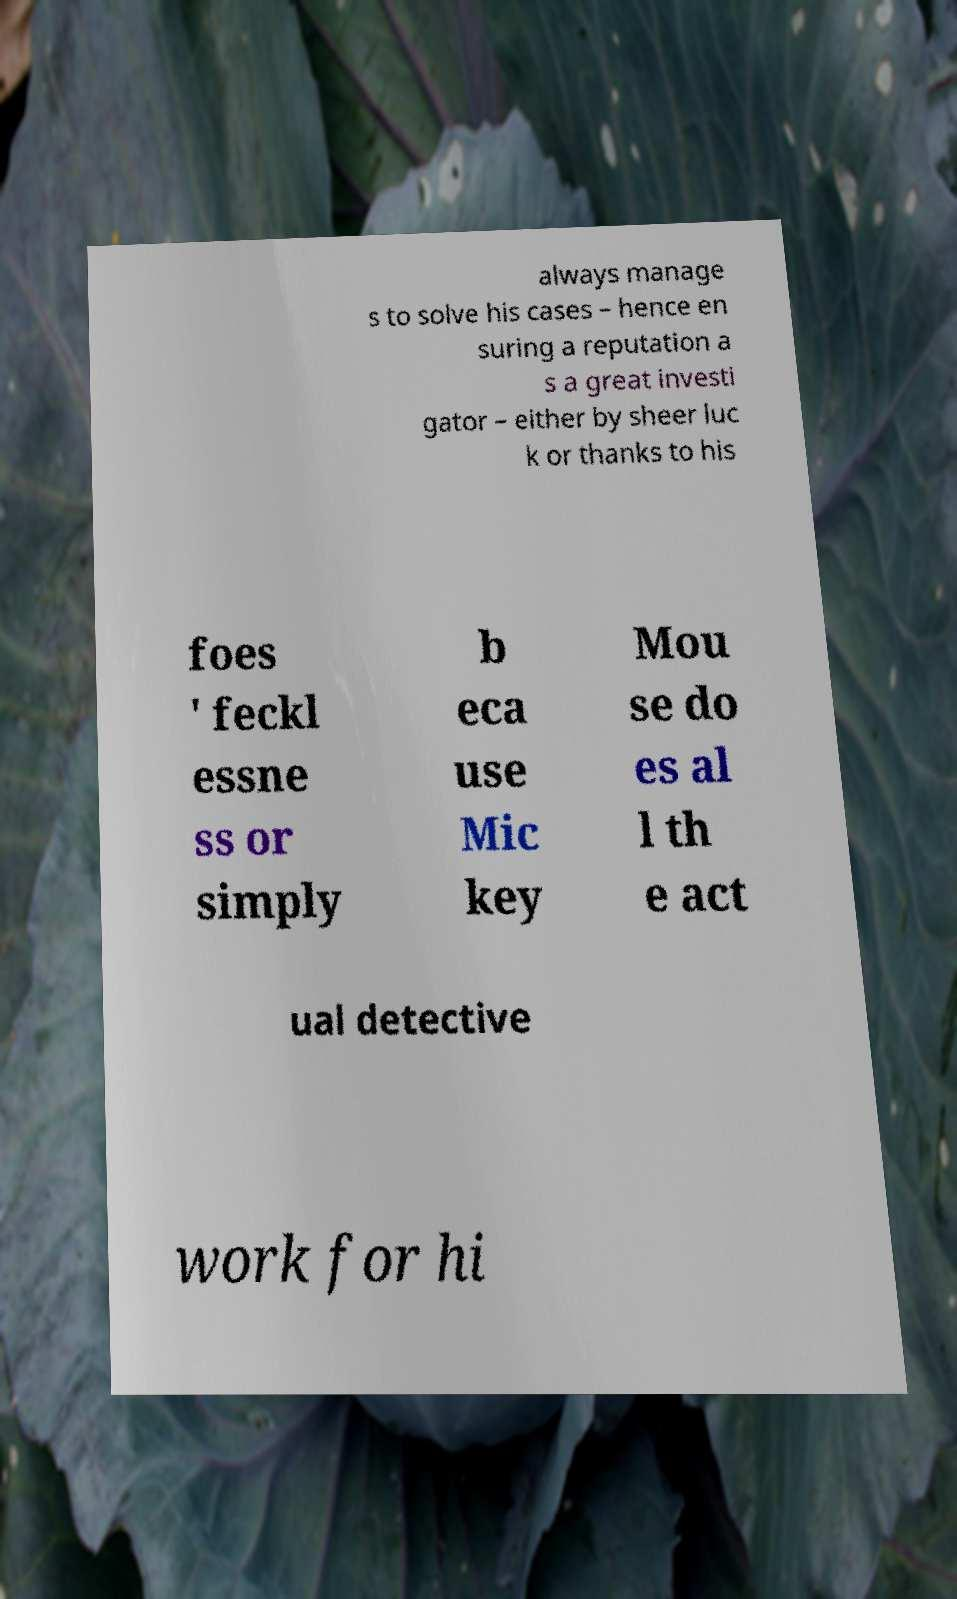Please identify and transcribe the text found in this image. always manage s to solve his cases – hence en suring a reputation a s a great investi gator – either by sheer luc k or thanks to his foes ' feckl essne ss or simply b eca use Mic key Mou se do es al l th e act ual detective work for hi 